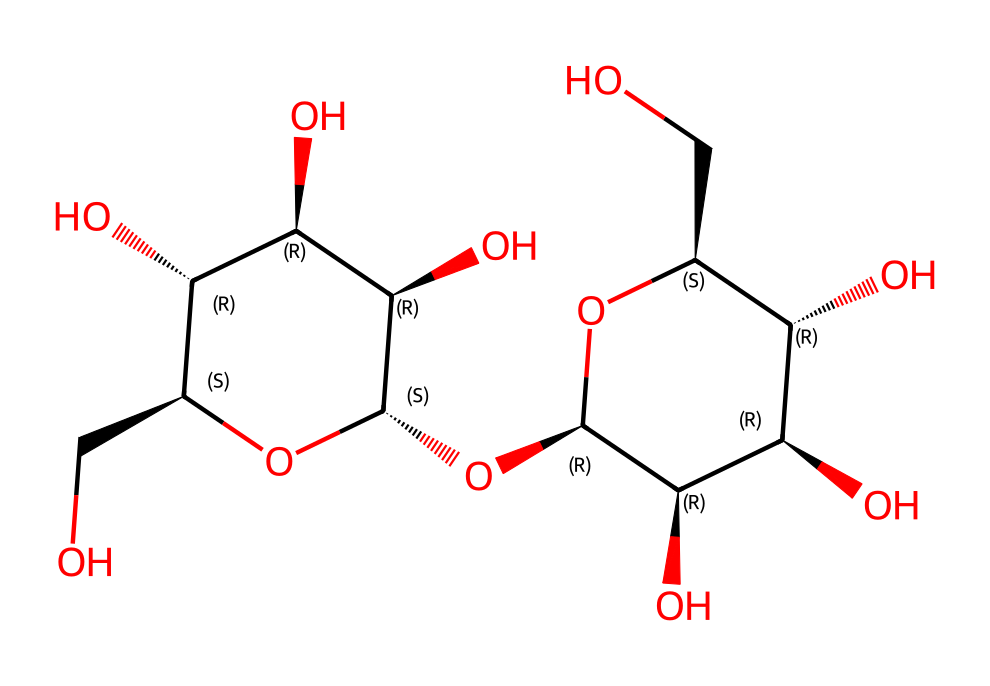What is the molecular formula of microcrystalline cellulose? By analyzing the SMILES representation, we can count the carbon (C), hydrogen (H), and oxygen (O) atoms present. The structure indicates numerous hydroxyl (-OH) groups, which are typical in cellulose. The total count gives us the molecular formula: C6H10O5 based on the repeated units in cellulose structure.
Answer: C6H10O5 How many hydroxyl groups are present in the structure? In the given SMILES, each hydroxyl group is represented by 'O' and is accompanied by hydrogen. By closely examining the SMILES, we observe that there are 5 hydroxyl groups due to the multiple 'O' symbols present in the sequence.
Answer: 5 Is microcrystalline cellulose soluble in water? Understanding the presence of multiple hydroxyl groups in the structure, we know that these groups can form hydrogen bonds with water molecules, indicating a high degree of water solubility. Therefore, based on its chemical properties, microcrystalline cellulose is indeed soluble in water.
Answer: Yes What type of polymer is microcrystalline cellulose? Microcrystalline cellulose is a cellulose derivative. Cellulose is a polysaccharide, which means it is a type of polymer made up of repeating sugar units, primarily glucose units linked together. Given this classification, we can categorize microcrystalline cellulose as a polysaccharide.
Answer: Polysaccharide How does the structure of microcrystalline cellulose contribute to its biodegradable properties? The presence of multiple hydroxyl groups allows for easy breakdown by microbial enzymes. The structural integrity of cellulose is based on β(1→4) glycosidic bonds, which are readily hydrolyzed by cellulase, a common enzyme produced by bacteria and fungi. Thus, the structure provides a pathway for biodegradation.
Answer: Hydroxyl groups What is the primary role of microcrystalline cellulose in cosmetics? Microcrystalline cellulose is primarily used as a bulking agent and texturizer. Its structure allows it to provide a creamy feel, improve viscosity, and stabilize products, making it valuable in various cosmetic formulations.
Answer: Bulking agent 